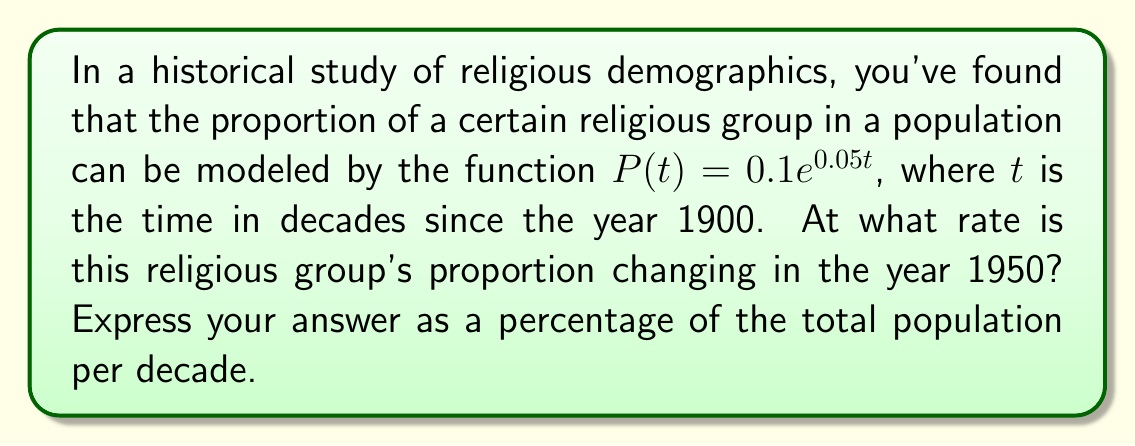Could you help me with this problem? To solve this problem, we need to follow these steps:

1) The rate of change of the proportion is given by the derivative of $P(t)$ with respect to $t$.

2) Let's find the derivative:
   $$\frac{dP}{dt} = 0.1 \cdot 0.05e^{0.05t} = 0.005e^{0.05t}$$

3) We need to evaluate this at $t = 5$ (since 1950 is 5 decades after 1900):
   $$\left.\frac{dP}{dt}\right|_{t=5} = 0.005e^{0.05(5)} = 0.005e^{0.25}$$

4) Let's calculate this value:
   $$0.005e^{0.25} \approx 0.00641$$

5) This represents the rate of change per decade. To express it as a percentage, we multiply by 100:
   $$0.00641 \cdot 100 \approx 0.641\%$$

Therefore, in 1950, the religious group's proportion is increasing at a rate of approximately 0.641% of the total population per decade.
Answer: 0.641% per decade 